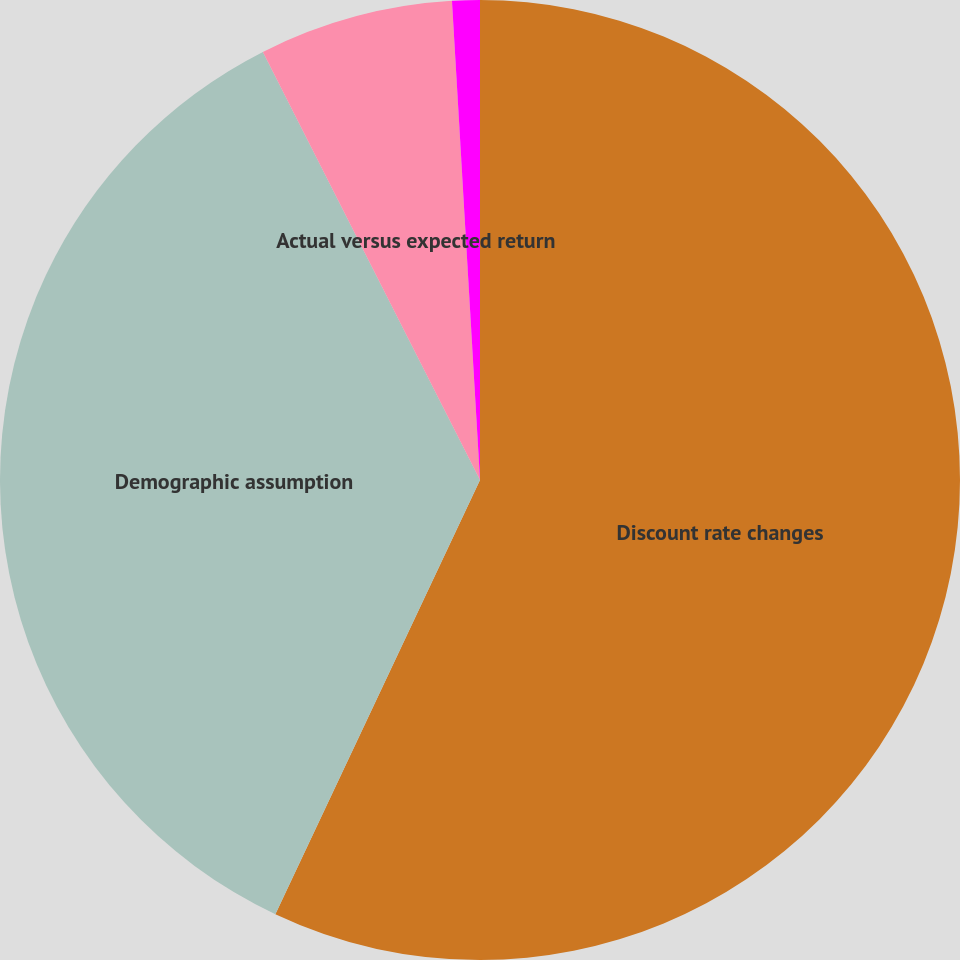Convert chart. <chart><loc_0><loc_0><loc_500><loc_500><pie_chart><fcel>Discount rate changes<fcel>Demographic assumption<fcel>Actual versus expected return<fcel>Total mark-to-market (gain)<nl><fcel>57.01%<fcel>35.52%<fcel>6.54%<fcel>0.93%<nl></chart> 